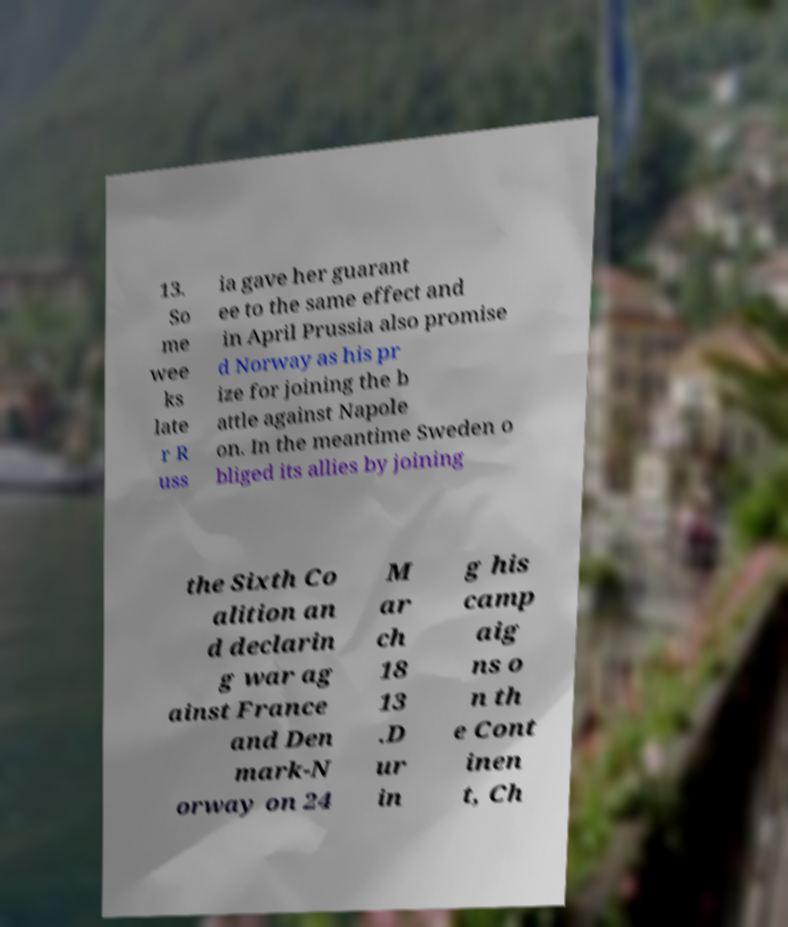Can you accurately transcribe the text from the provided image for me? 13. So me wee ks late r R uss ia gave her guarant ee to the same effect and in April Prussia also promise d Norway as his pr ize for joining the b attle against Napole on. In the meantime Sweden o bliged its allies by joining the Sixth Co alition an d declarin g war ag ainst France and Den mark-N orway on 24 M ar ch 18 13 .D ur in g his camp aig ns o n th e Cont inen t, Ch 